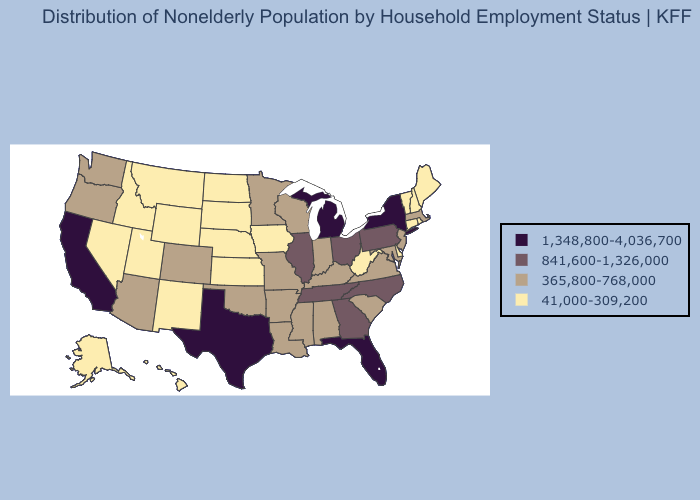What is the lowest value in the Northeast?
Answer briefly. 41,000-309,200. Which states have the highest value in the USA?
Concise answer only. California, Florida, Michigan, New York, Texas. Does New York have the highest value in the Northeast?
Concise answer only. Yes. Does Texas have the highest value in the USA?
Short answer required. Yes. Does the map have missing data?
Quick response, please. No. Name the states that have a value in the range 41,000-309,200?
Keep it brief. Alaska, Connecticut, Delaware, Hawaii, Idaho, Iowa, Kansas, Maine, Montana, Nebraska, Nevada, New Hampshire, New Mexico, North Dakota, Rhode Island, South Dakota, Utah, Vermont, West Virginia, Wyoming. Does South Carolina have the highest value in the USA?
Write a very short answer. No. What is the value of Alabama?
Be succinct. 365,800-768,000. How many symbols are there in the legend?
Keep it brief. 4. Does Florida have the highest value in the USA?
Short answer required. Yes. Name the states that have a value in the range 1,348,800-4,036,700?
Answer briefly. California, Florida, Michigan, New York, Texas. Does Mississippi have the same value as South Dakota?
Concise answer only. No. Which states have the highest value in the USA?
Write a very short answer. California, Florida, Michigan, New York, Texas. What is the value of Tennessee?
Answer briefly. 841,600-1,326,000. What is the value of Oklahoma?
Write a very short answer. 365,800-768,000. 